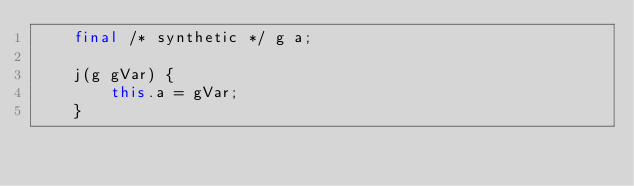<code> <loc_0><loc_0><loc_500><loc_500><_Java_>    final /* synthetic */ g a;

    j(g gVar) {
        this.a = gVar;
    }
</code> 